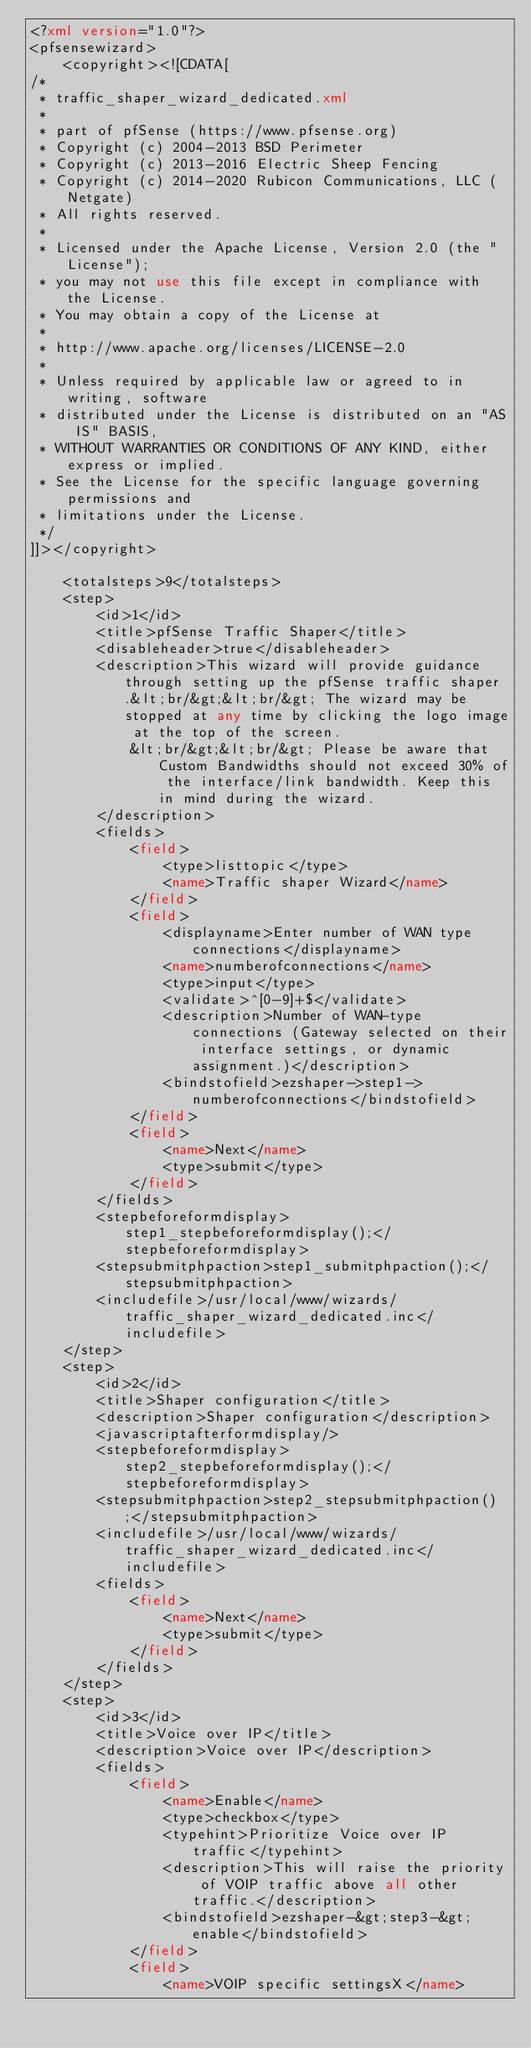Convert code to text. <code><loc_0><loc_0><loc_500><loc_500><_XML_><?xml version="1.0"?>
<pfsensewizard>
	<copyright><![CDATA[
/*
 * traffic_shaper_wizard_dedicated.xml
 *
 * part of pfSense (https://www.pfsense.org)
 * Copyright (c) 2004-2013 BSD Perimeter
 * Copyright (c) 2013-2016 Electric Sheep Fencing
 * Copyright (c) 2014-2020 Rubicon Communications, LLC (Netgate)
 * All rights reserved.
 *
 * Licensed under the Apache License, Version 2.0 (the "License");
 * you may not use this file except in compliance with the License.
 * You may obtain a copy of the License at
 *
 * http://www.apache.org/licenses/LICENSE-2.0
 *
 * Unless required by applicable law or agreed to in writing, software
 * distributed under the License is distributed on an "AS IS" BASIS,
 * WITHOUT WARRANTIES OR CONDITIONS OF ANY KIND, either express or implied.
 * See the License for the specific language governing permissions and
 * limitations under the License.
 */
]]></copyright>

	<totalsteps>9</totalsteps>
	<step>
		<id>1</id>
		<title>pfSense Traffic Shaper</title>
		<disableheader>true</disableheader>
		<description>This wizard will provide guidance through setting up the pfSense traffic shaper.&lt;br/&gt;&lt;br/&gt; The wizard may be stopped at any time by clicking the logo image at the top of the screen.
			&lt;br/&gt;&lt;br/&gt; Please be aware that Custom Bandwidths should not exceed 30% of the interface/link bandwidth. Keep this in mind during the wizard.
		</description>
		<fields>
			<field>
				<type>listtopic</type>
				<name>Traffic shaper Wizard</name>
			</field>
			<field>
				<displayname>Enter number of WAN type connections</displayname>
				<name>numberofconnections</name>
				<type>input</type>
				<validate>^[0-9]+$</validate>
				<description>Number of WAN-type connections (Gateway selected on their interface settings, or dynamic assignment.)</description>
				<bindstofield>ezshaper->step1->numberofconnections</bindstofield>
			</field>
			<field>
				<name>Next</name>
				<type>submit</type>
			</field>
		</fields>
		<stepbeforeformdisplay>step1_stepbeforeformdisplay();</stepbeforeformdisplay>
		<stepsubmitphpaction>step1_submitphpaction();</stepsubmitphpaction>
		<includefile>/usr/local/www/wizards/traffic_shaper_wizard_dedicated.inc</includefile>
	</step>
	<step>
		<id>2</id>
		<title>Shaper configuration</title>
		<description>Shaper configuration</description>
		<javascriptafterformdisplay/>
		<stepbeforeformdisplay>step2_stepbeforeformdisplay();</stepbeforeformdisplay>
		<stepsubmitphpaction>step2_stepsubmitphpaction();</stepsubmitphpaction>
		<includefile>/usr/local/www/wizards/traffic_shaper_wizard_dedicated.inc</includefile>
		<fields>
			<field>
				<name>Next</name>
				<type>submit</type>
			</field>
		</fields>
	</step>
	<step>
		<id>3</id>
		<title>Voice over IP</title>
		<description>Voice over IP</description>
		<fields>
			<field>
				<name>Enable</name>
				<type>checkbox</type>
				<typehint>Prioritize Voice over IP traffic</typehint>
				<description>This will raise the priority of VOIP traffic above all other traffic.</description>
				<bindstofield>ezshaper-&gt;step3-&gt;enable</bindstofield>
			</field>
			<field>
				<name>VOIP specific settingsX</name></code> 